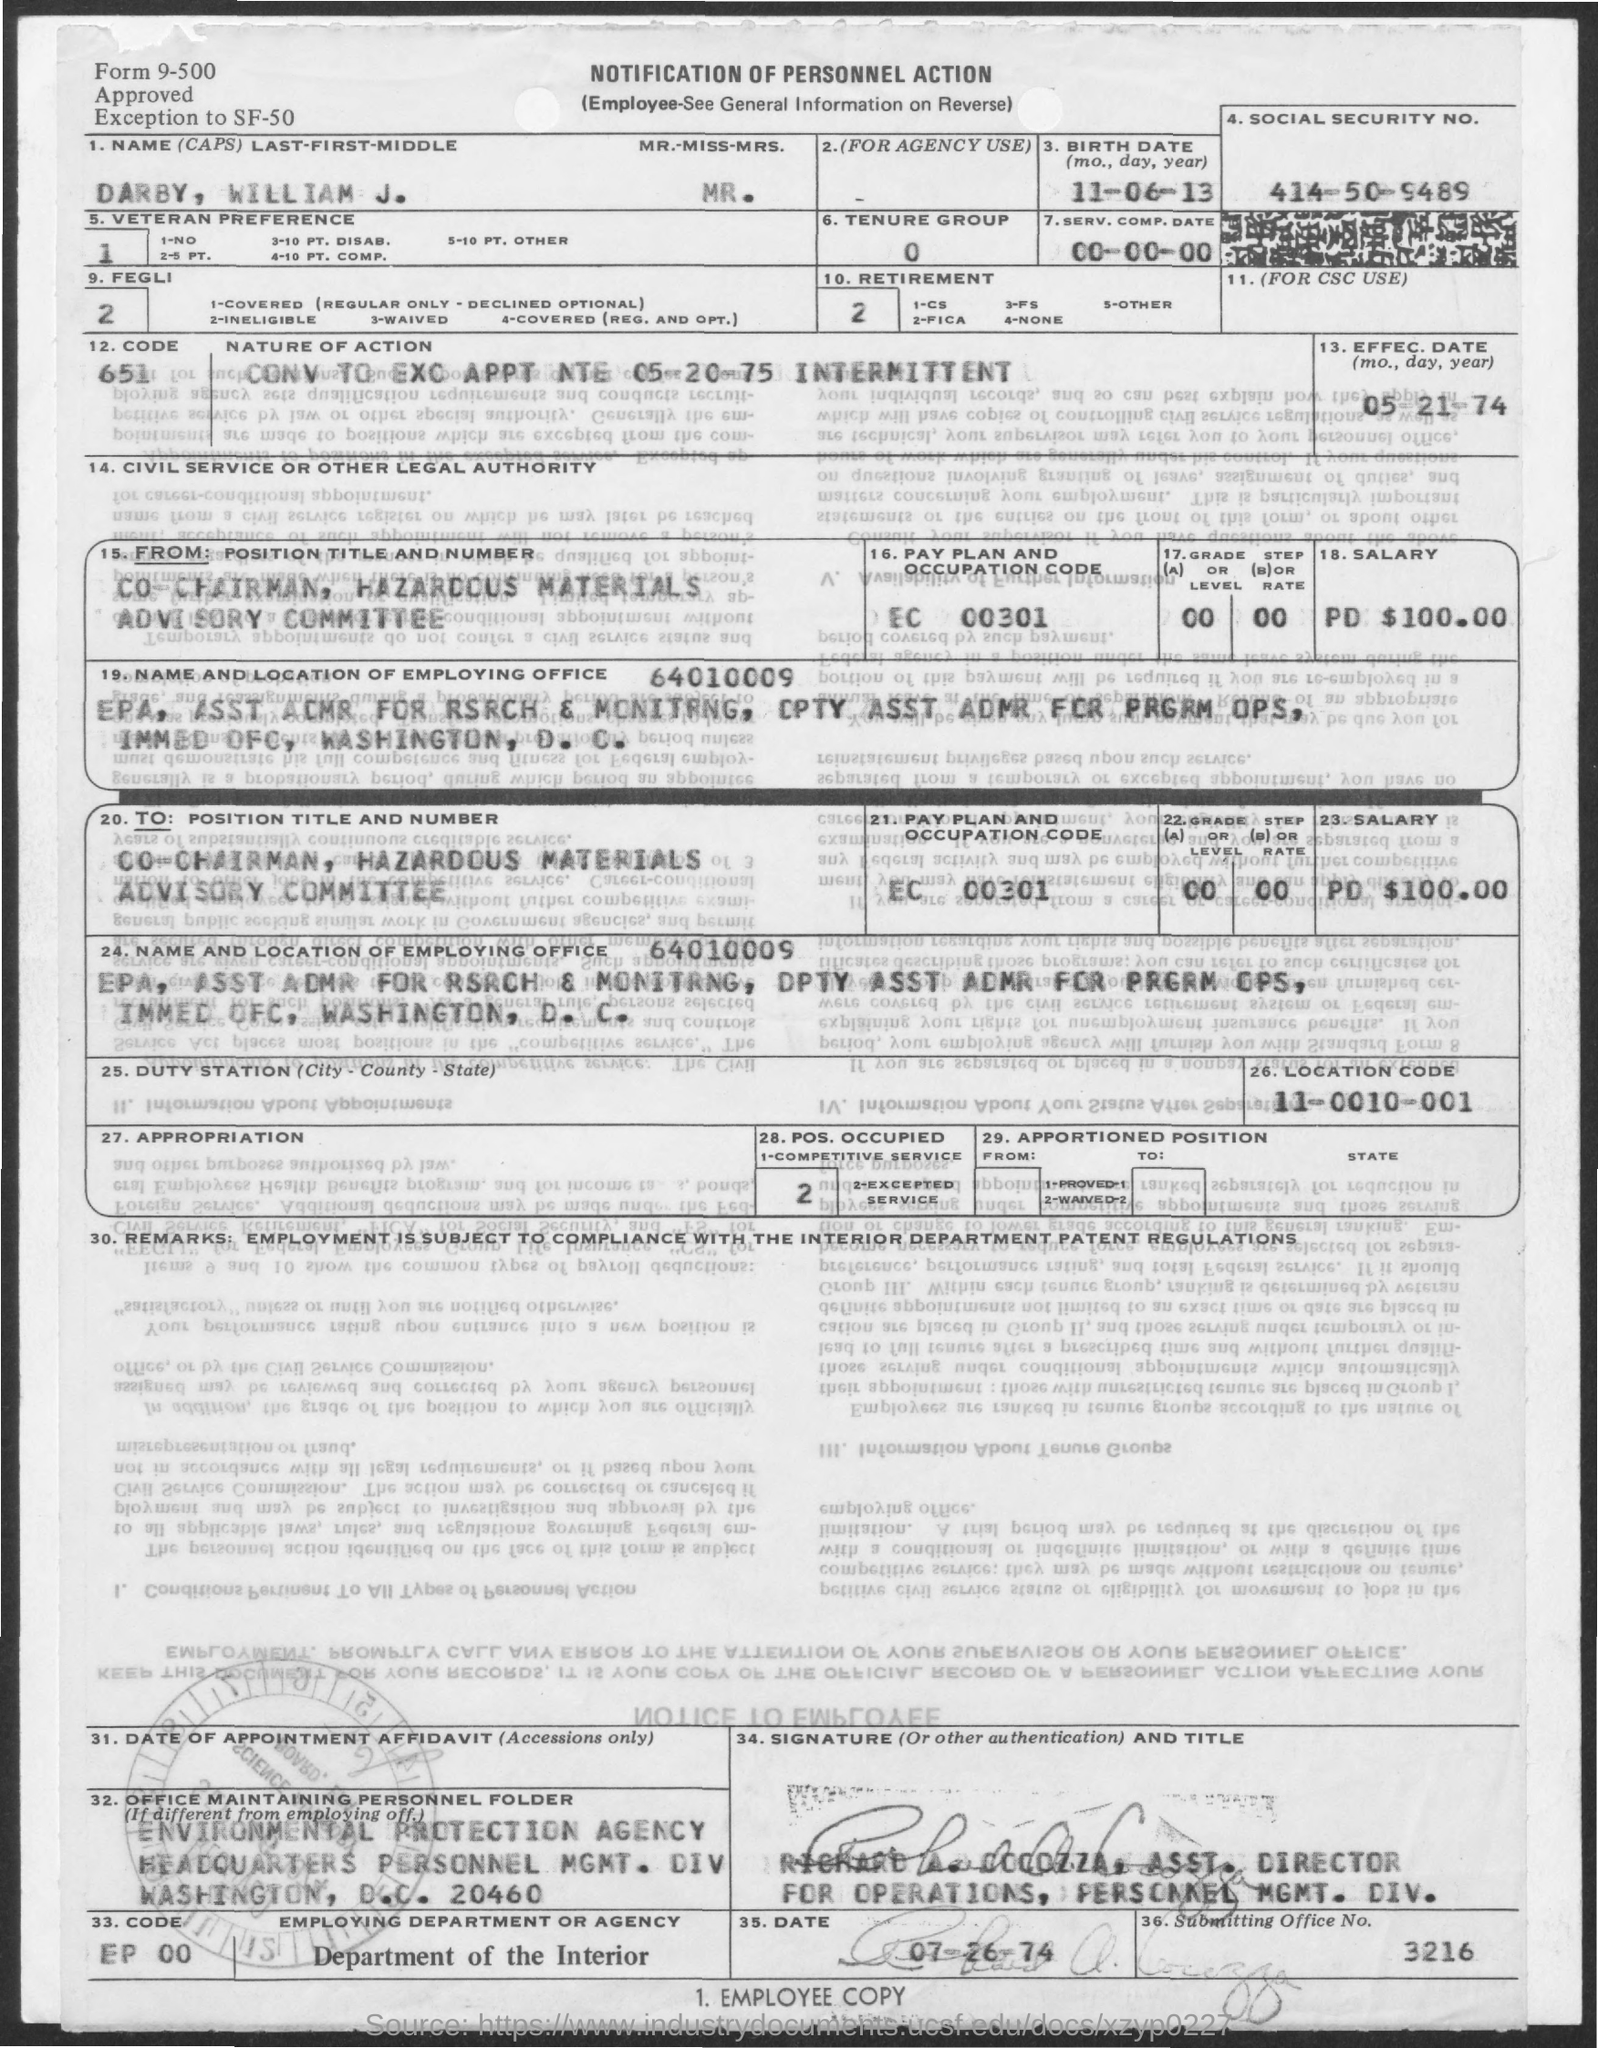Mention a couple of crucial points in this snapshot. The Department of the Interior is the employing department or agency. The name of the individual is William J. Darby, and their last-first-middle is listed as such. What is the salary? The salary is PD $100.00. The Location Code is 11-0010-001. The Submitting Office Number is 3216. 